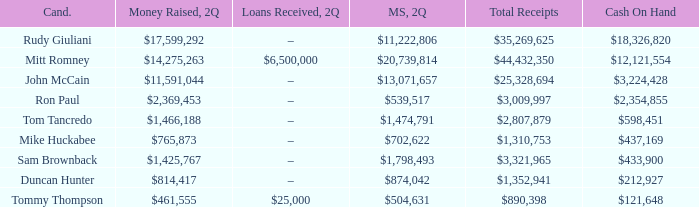Tell me the money raised when 2Q has total receipts of $890,398 $461,555. 